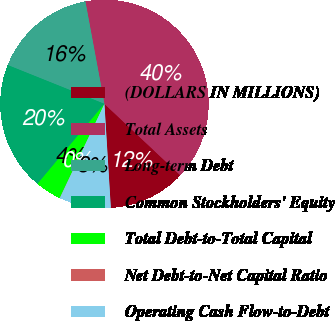<chart> <loc_0><loc_0><loc_500><loc_500><pie_chart><fcel>(DOLLARS IN MILLIONS)<fcel>Total Assets<fcel>Long-term Debt<fcel>Common Stockholders' Equity<fcel>Total Debt-to-Total Capital<fcel>Net Debt-to-Net Capital Ratio<fcel>Operating Cash Flow-to-Debt<nl><fcel>12.01%<fcel>39.94%<fcel>16.0%<fcel>19.99%<fcel>4.02%<fcel>0.03%<fcel>8.01%<nl></chart> 